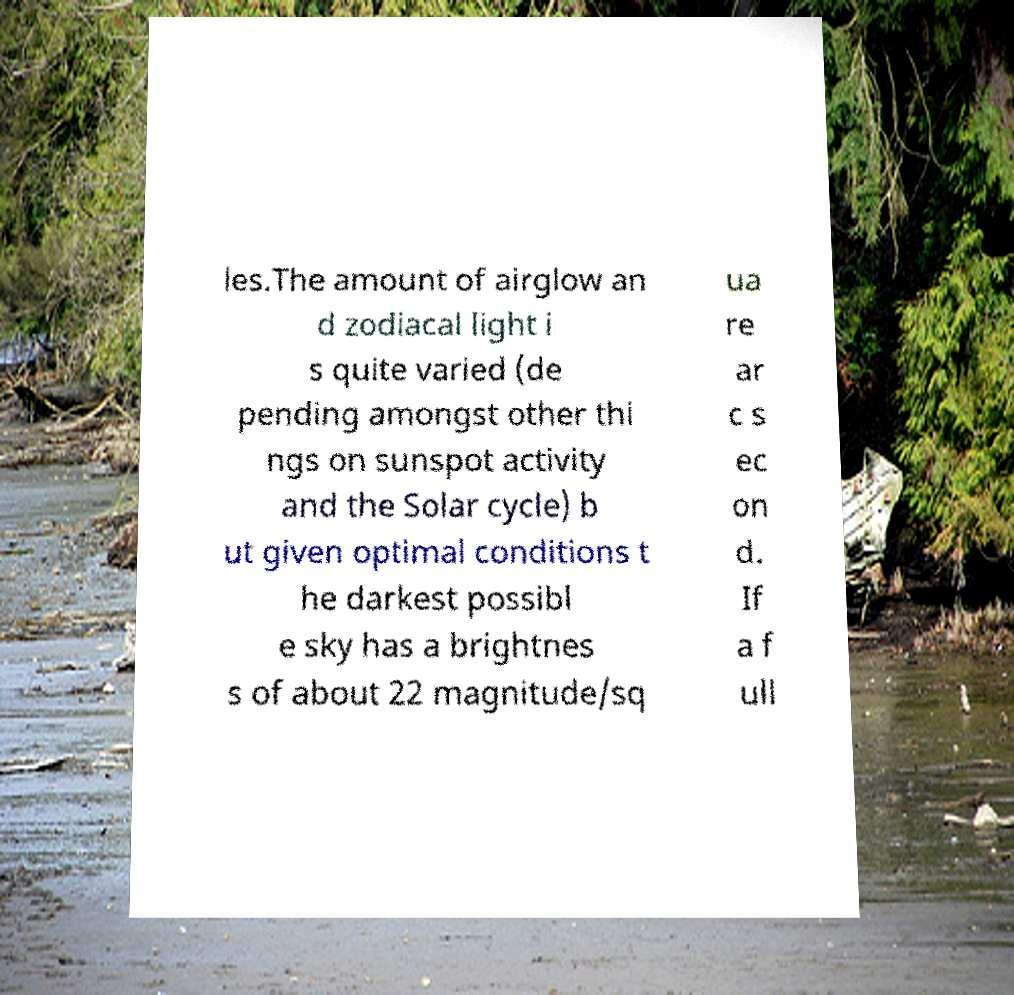What messages or text are displayed in this image? I need them in a readable, typed format. les.The amount of airglow an d zodiacal light i s quite varied (de pending amongst other thi ngs on sunspot activity and the Solar cycle) b ut given optimal conditions t he darkest possibl e sky has a brightnes s of about 22 magnitude/sq ua re ar c s ec on d. If a f ull 